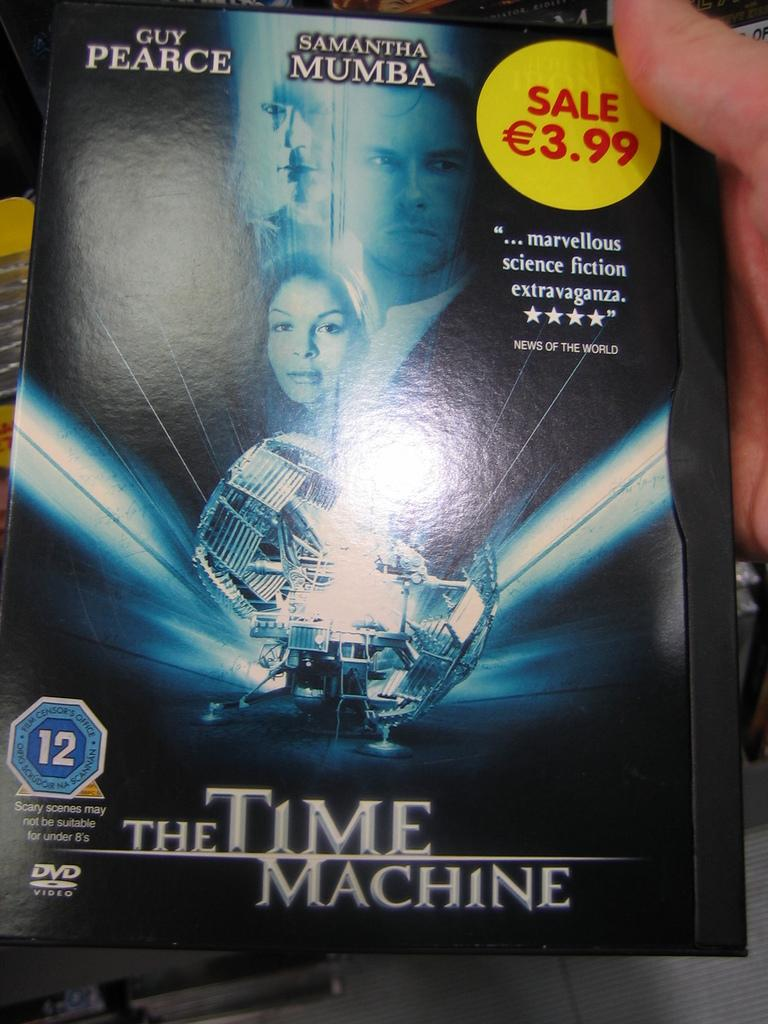<image>
Describe the image concisely. A DVD on sale titled "The Time Machine". 